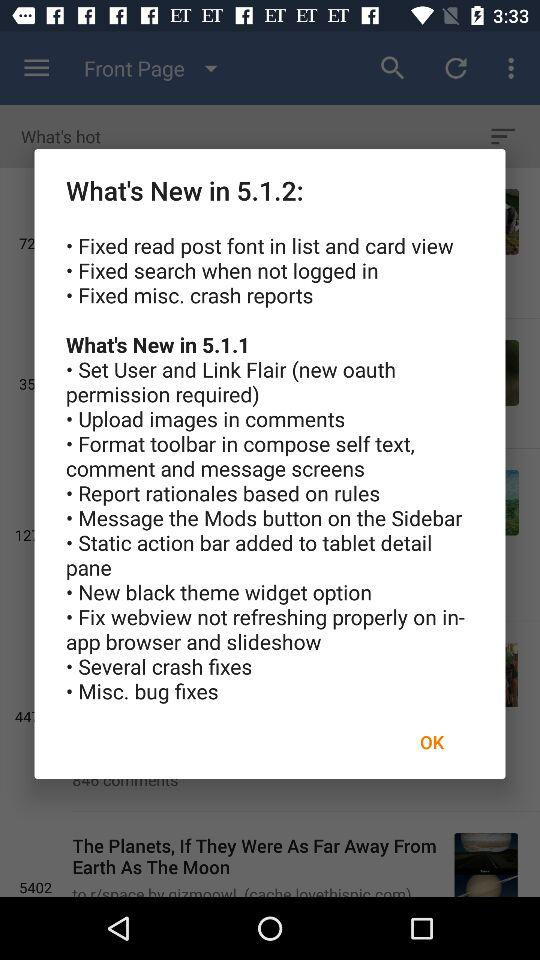What things are fixed in the new version 5.1.2? The things that are fixed are "Fixed read post font in list and card view", "Fixed search when not logged in" and "Fixed misc. crash reports". 